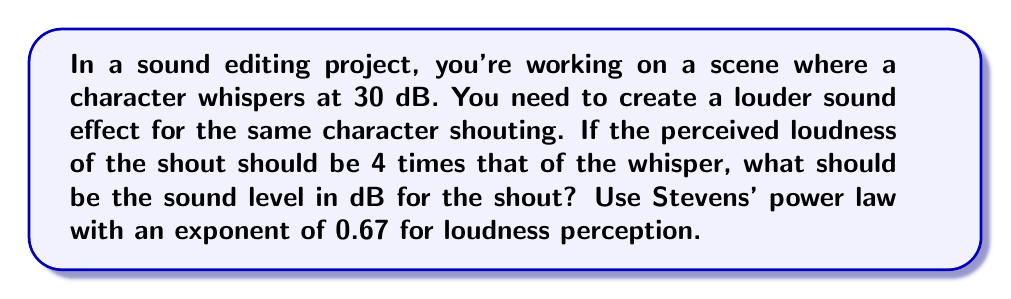Solve this math problem. Let's approach this step-by-step using Stevens' power law:

1) Stevens' power law states that the perceived magnitude of a stimulus (Ψ) is related to its physical intensity (I) by:

   $$ \Psi = k I^n $$

   where k is a constant and n is the power exponent (0.67 for loudness).

2) We're told that the perceived loudness of the shout should be 4 times that of the whisper. Let's call the whisper's perceived loudness Ψ₁ and the shout's Ψ₂:

   $$ \Psi_2 = 4\Psi_1 $$

3) The whisper is at 30 dB. We need to convert this to intensity. The relationship between dB and intensity is:

   $$ dB = 10 \log_{10}(\frac{I}{I_0}) $$

   where I₀ is the reference intensity.

4) For the whisper (I₁):

   $$ 30 = 10 \log_{10}(\frac{I_1}{I_0}) $$
   $$ \frac{I_1}{I_0} = 10^3 $$

5) Now, let's apply Stevens' power law to both sounds:

   $$ \Psi_1 = k (10^3)^{0.67} $$
   $$ \Psi_2 = k (\frac{I_2}{I_0})^{0.67} $$

6) Dividing these equations:

   $$ \frac{\Psi_2}{\Psi_1} = \frac{k (\frac{I_2}{I_0})^{0.67}}{k (10^3)^{0.67}} = (\frac{I_2}{I_0 \cdot 10^3})^{0.67} = 4 $$

7) Solving for I₂:

   $$ (\frac{I_2}{I_0 \cdot 10^3})^{0.67} = 4 $$
   $$ \frac{I_2}{I_0 \cdot 10^3} = 4^{\frac{1}{0.67}} \approx 37.6 $$
   $$ I_2 = 37.6 \cdot I_0 \cdot 10^3 $$

8) Converting back to dB:

   $$ dB = 10 \log_{10}(37.6 \cdot 10^3) \approx 45.75 $$

Therefore, the sound level for the shout should be approximately 45.75 dB.
Answer: 45.75 dB 